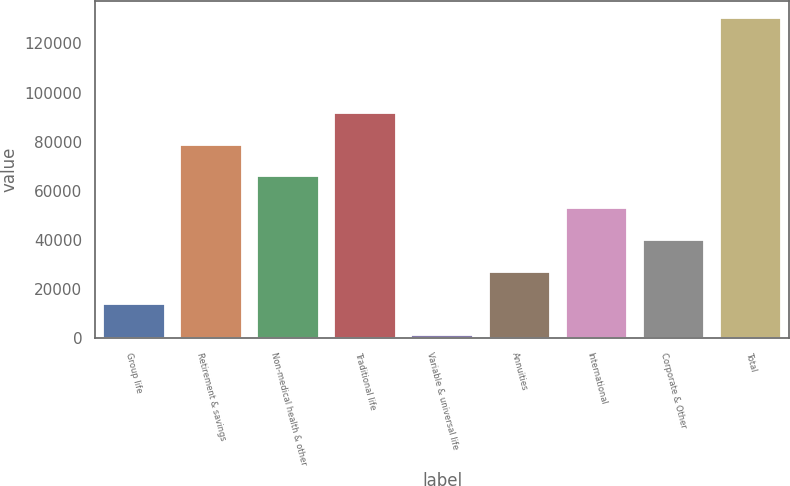Convert chart to OTSL. <chart><loc_0><loc_0><loc_500><loc_500><bar_chart><fcel>Group life<fcel>Retirement & savings<fcel>Non-medical health & other<fcel>Traditional life<fcel>Variable & universal life<fcel>Annuities<fcel>International<fcel>Corporate & Other<fcel>Total<nl><fcel>14071.6<fcel>78784.6<fcel>65842<fcel>91727.2<fcel>1129<fcel>27014.2<fcel>52899.4<fcel>39956.8<fcel>130555<nl></chart> 